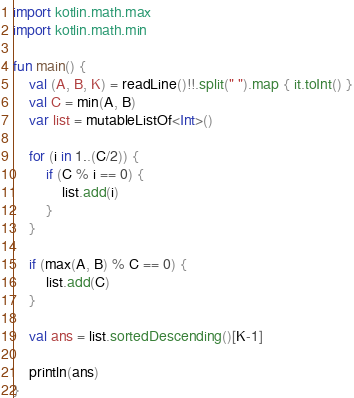<code> <loc_0><loc_0><loc_500><loc_500><_Kotlin_>import kotlin.math.max
import kotlin.math.min

fun main() {
    val (A, B, K) = readLine()!!.split(" ").map { it.toInt() }
    val C = min(A, B)
    var list = mutableListOf<Int>()

    for (i in 1..(C/2)) {
        if (C % i == 0) {
            list.add(i)
        }
    }

    if (max(A, B) % C == 0) {
        list.add(C)
    }

    val ans = list.sortedDescending()[K-1]

    println(ans)
}</code> 